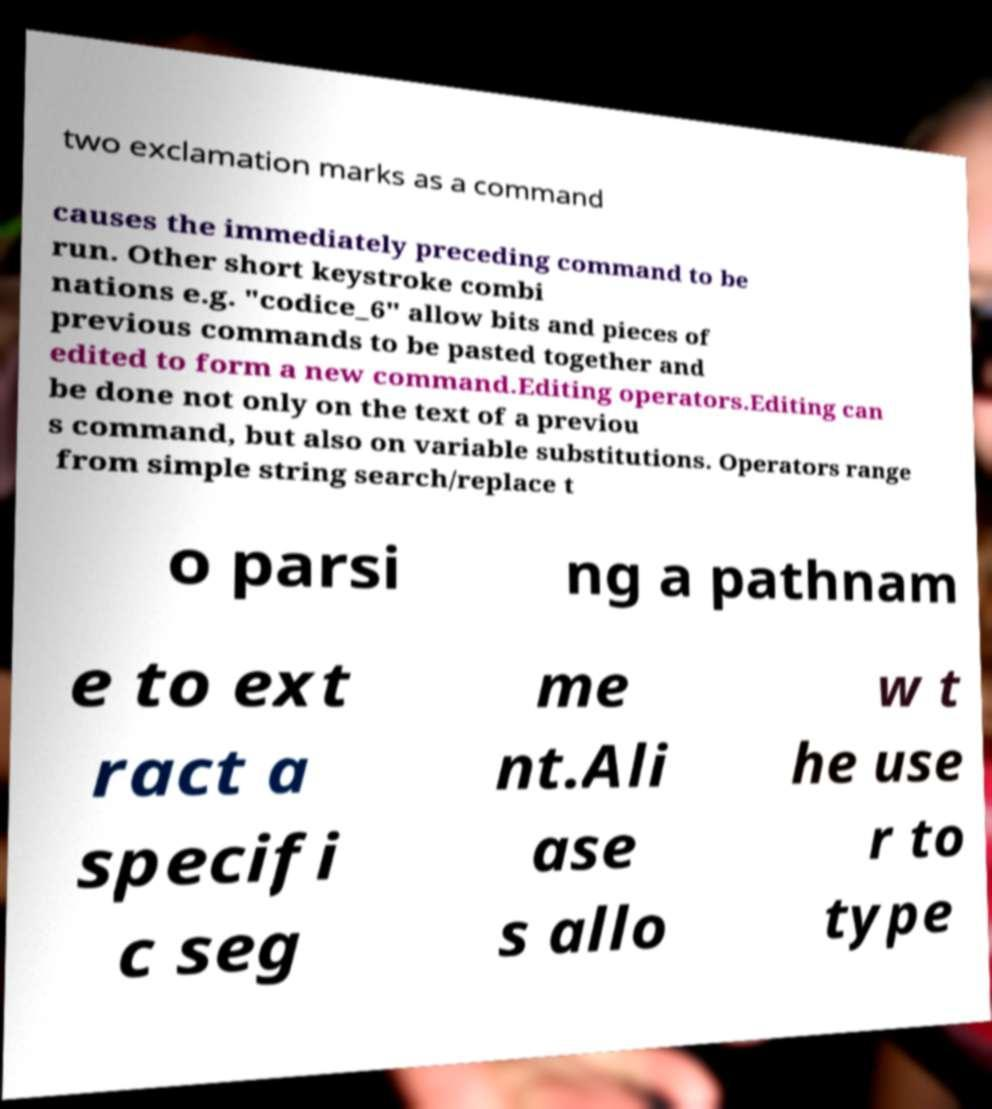For documentation purposes, I need the text within this image transcribed. Could you provide that? two exclamation marks as a command causes the immediately preceding command to be run. Other short keystroke combi nations e.g. "codice_6" allow bits and pieces of previous commands to be pasted together and edited to form a new command.Editing operators.Editing can be done not only on the text of a previou s command, but also on variable substitutions. Operators range from simple string search/replace t o parsi ng a pathnam e to ext ract a specifi c seg me nt.Ali ase s allo w t he use r to type 